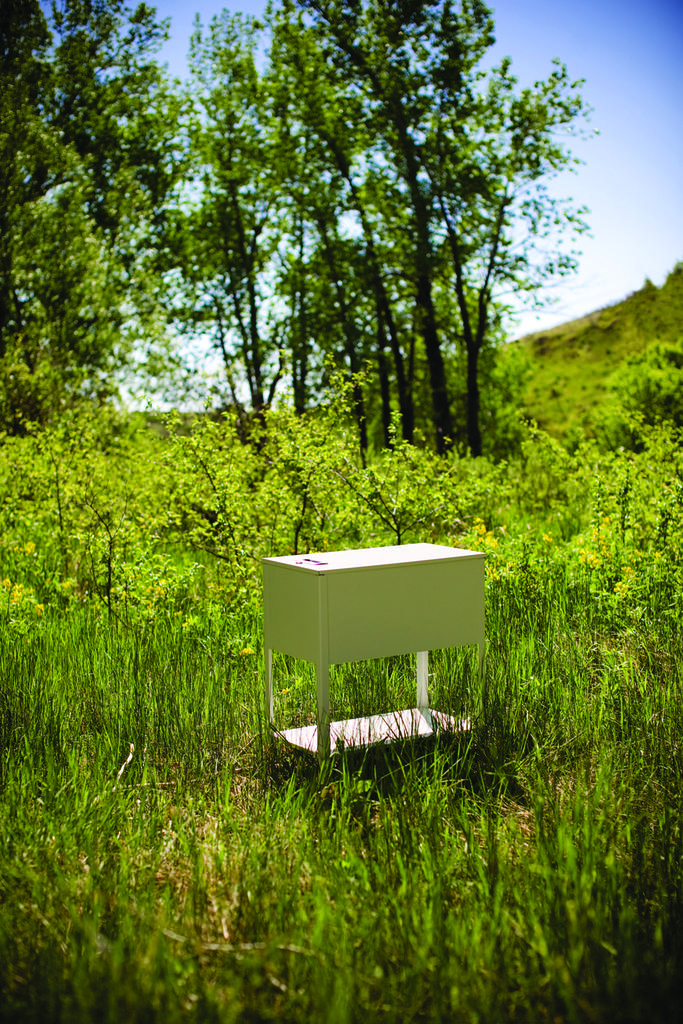What is the main object in the center of the image? There is a box in the center of the image. What is located at the bottom of the image? There are plants at the bottom of the image. What can be seen in the background of the image? There are trees in the background of the image. What is visible at the top of the image? The sky is visible at the top of the image. Can you describe the discussion happening between the ghost and the sofa in the image? There is no ghost or sofa present in the image, so there cannot be a discussion between them. 